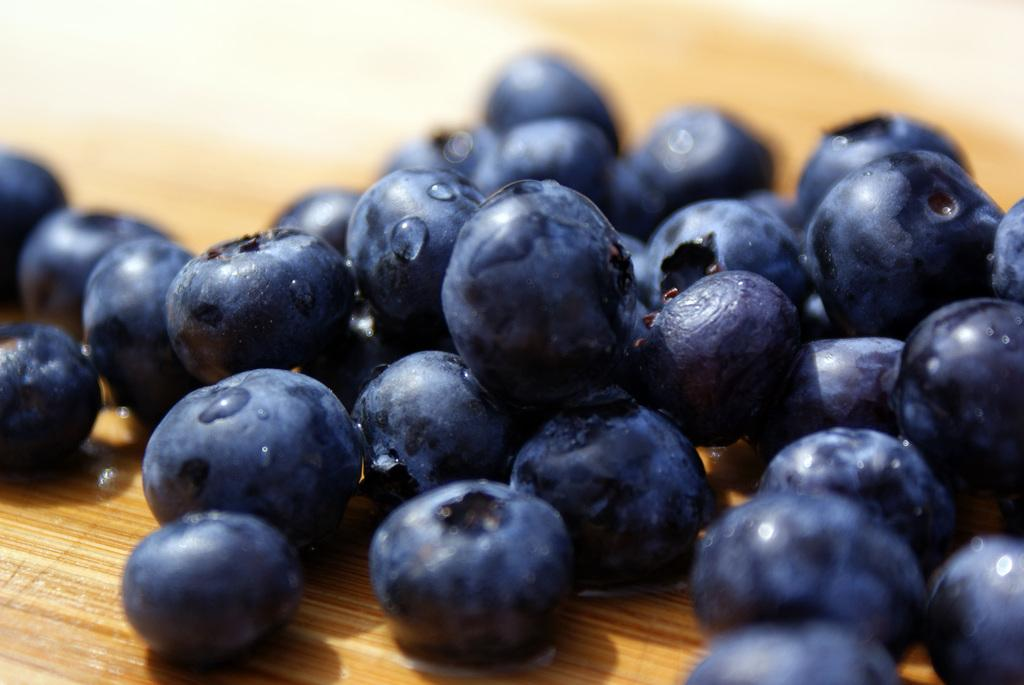What type of fruit can be seen in the image? There are berries in the image. On what surface are the berries placed? The berries are placed on a wooden surface. How many apples are visible in the image? There are no apples present in the image; it features berries on a wooden surface. Can you describe the insect that is crawling on the berries in the image? There is no insect present in the image; it only shows berries on a wooden surface. 